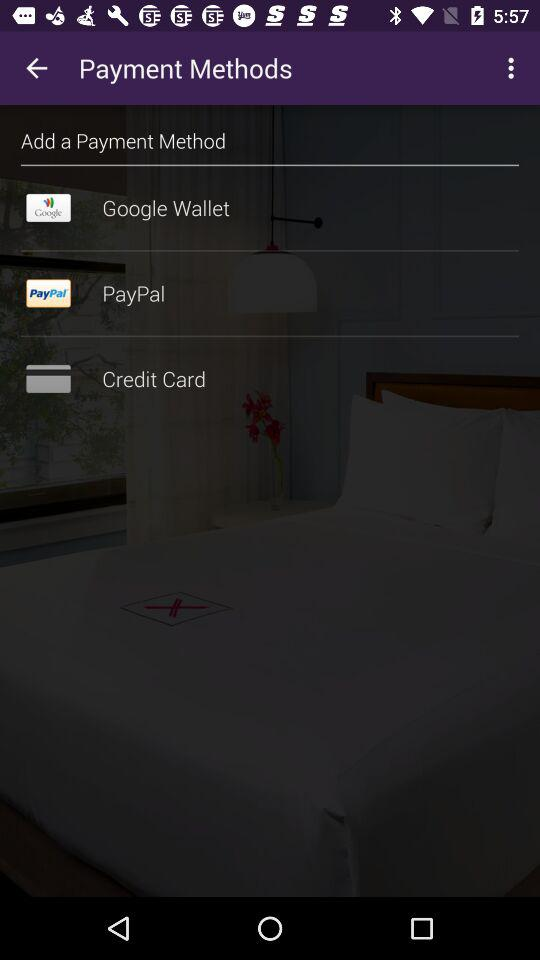What options are given for payment methods? The given options are "Google Wallet", "PayPal" and "Credit Card". 